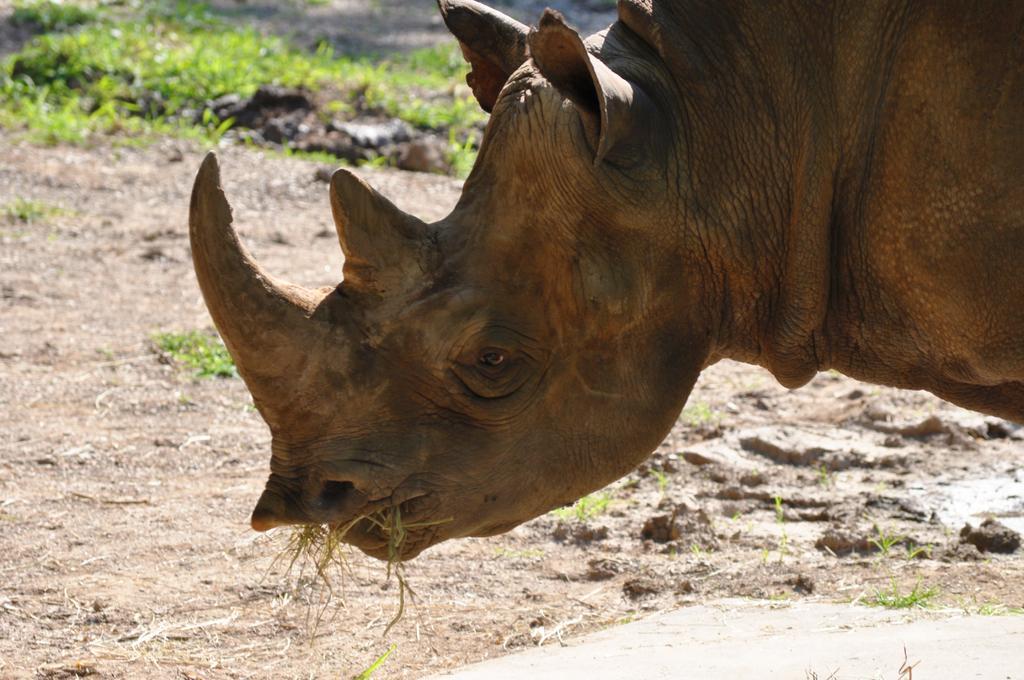Describe this image in one or two sentences. In this picture I can see a rhinoceros in front and there is grass in the mouth and I see the ground. In the background I see few more grass. 